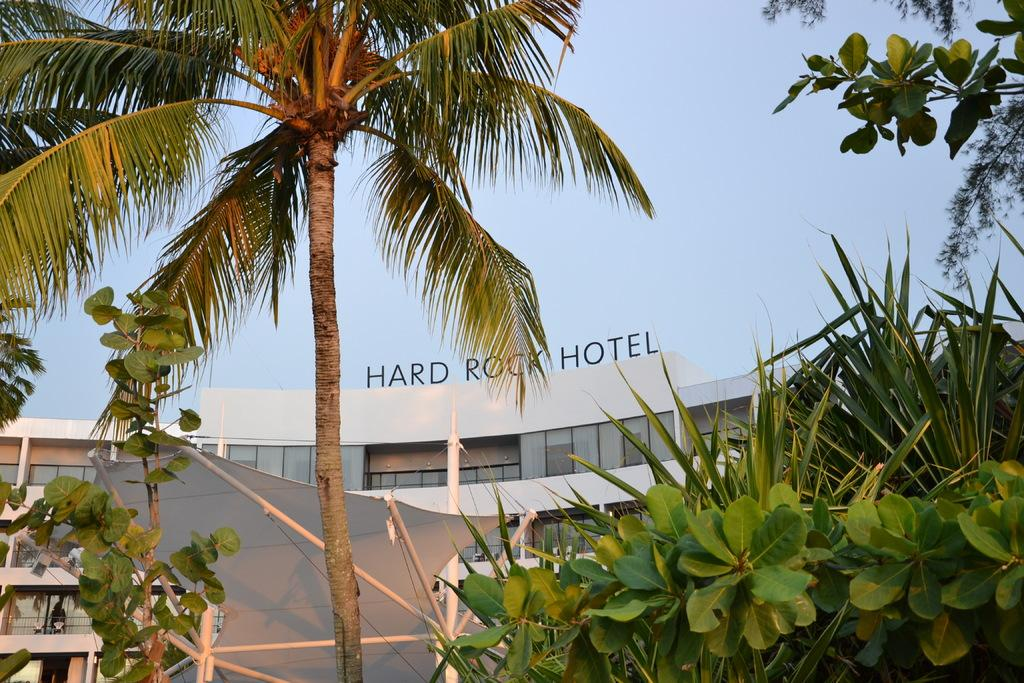What is placed on top of the building in the image? There is a name board on top of the building. What can be seen in front of the building? There are trees and plants in front of the building. What type of structure is located in front of the building? There is a shed in front of the building. What is visible in the background of the image? The sky is visible in the background. What historical event is being commemorated by the name board in the image? The image does not provide any information about the historical event being commemorated by the name board. 